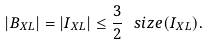Convert formula to latex. <formula><loc_0><loc_0><loc_500><loc_500>| B _ { X L } | = | I _ { X L } | \leq \frac { 3 } { 2 } \, \ s i z e ( I _ { X L } ) .</formula> 